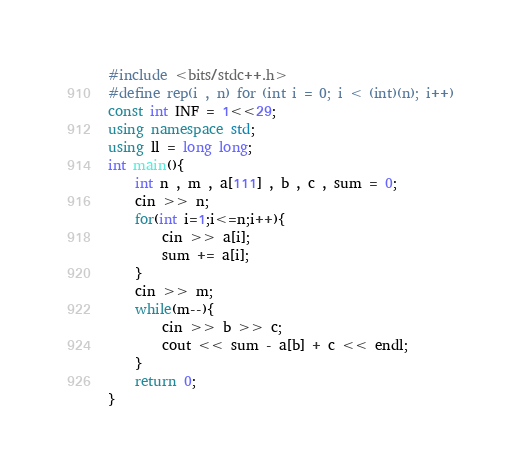Convert code to text. <code><loc_0><loc_0><loc_500><loc_500><_C++_>#include <bits/stdc++.h>
#define rep(i , n) for (int i = 0; i < (int)(n); i++)
const int INF = 1<<29;
using namespace std;
using ll = long long;
int main(){
    int n , m , a[111] , b , c , sum = 0;
	cin >> n;
	for(int i=1;i<=n;i++){
	    cin >> a[i];
        sum += a[i];
    }
	cin >> m;
	while(m--){
	    cin >> b >> c;
        cout << sum - a[b] + c << endl; 
    }
	return 0;
}
</code> 